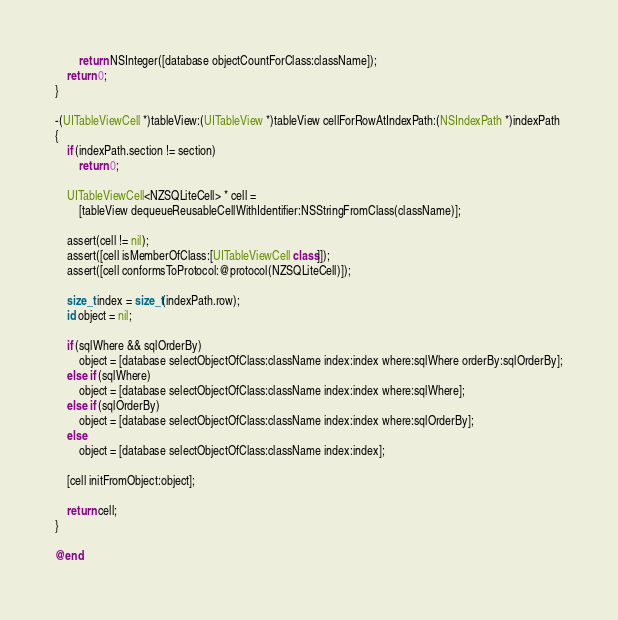<code> <loc_0><loc_0><loc_500><loc_500><_ObjectiveC_>		return NSInteger([database objectCountForClass:className]);
	return 0;
}

-(UITableViewCell *)tableView:(UITableView *)tableView cellForRowAtIndexPath:(NSIndexPath *)indexPath
{
	if (indexPath.section != section)
		return 0;

	UITableViewCell<NZSQLiteCell> * cell =
		[tableView dequeueReusableCellWithIdentifier:NSStringFromClass(className)];

	assert(cell != nil);
	assert([cell isMemberOfClass:[UITableViewCell class]]);
	assert([cell conformsToProtocol:@protocol(NZSQLiteCell)]);

	size_t index = size_t(indexPath.row);
	id object = nil;

	if (sqlWhere && sqlOrderBy)
		object = [database selectObjectOfClass:className index:index where:sqlWhere orderBy:sqlOrderBy];
	else if (sqlWhere)
		object = [database selectObjectOfClass:className index:index where:sqlWhere];
	else if (sqlOrderBy)
		object = [database selectObjectOfClass:className index:index where:sqlOrderBy];
	else
		object = [database selectObjectOfClass:className index:index];

	[cell initFromObject:object];

	return cell;
}

@end
</code> 